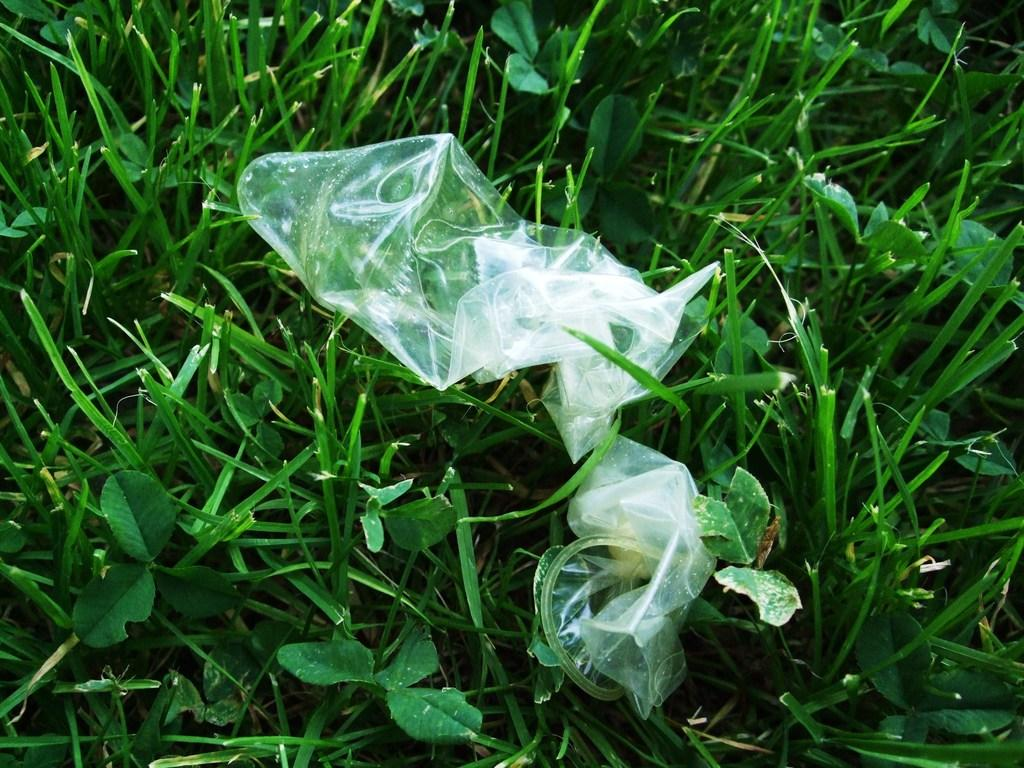What type of surface can be seen in the image? There is grass in the image. What is placed on the grass? There are objects on the grass. How many birds are sitting on the objects on the grass? There is no bird present in the image. What type of camp can be seen in the image? There is no camp present in the image. 